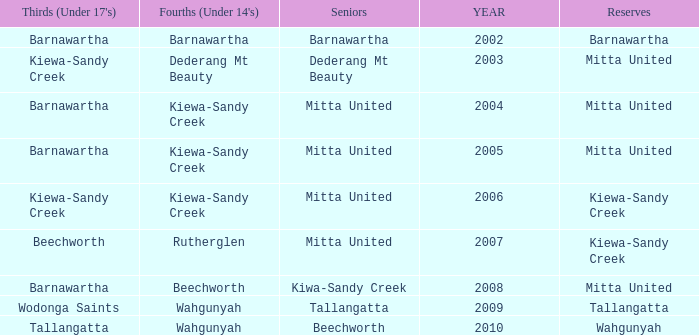Which seniors have a year after 2005, a Reserve of kiewa-sandy creek, and Fourths (Under 14's) of kiewa-sandy creek? Mitta United. Help me parse the entirety of this table. {'header': ["Thirds (Under 17's)", "Fourths (Under 14's)", 'Seniors', 'YEAR', 'Reserves'], 'rows': [['Barnawartha', 'Barnawartha', 'Barnawartha', '2002', 'Barnawartha'], ['Kiewa-Sandy Creek', 'Dederang Mt Beauty', 'Dederang Mt Beauty', '2003', 'Mitta United'], ['Barnawartha', 'Kiewa-Sandy Creek', 'Mitta United', '2004', 'Mitta United'], ['Barnawartha', 'Kiewa-Sandy Creek', 'Mitta United', '2005', 'Mitta United'], ['Kiewa-Sandy Creek', 'Kiewa-Sandy Creek', 'Mitta United', '2006', 'Kiewa-Sandy Creek'], ['Beechworth', 'Rutherglen', 'Mitta United', '2007', 'Kiewa-Sandy Creek'], ['Barnawartha', 'Beechworth', 'Kiwa-Sandy Creek', '2008', 'Mitta United'], ['Wodonga Saints', 'Wahgunyah', 'Tallangatta', '2009', 'Tallangatta'], ['Tallangatta', 'Wahgunyah', 'Beechworth', '2010', 'Wahgunyah']]} 